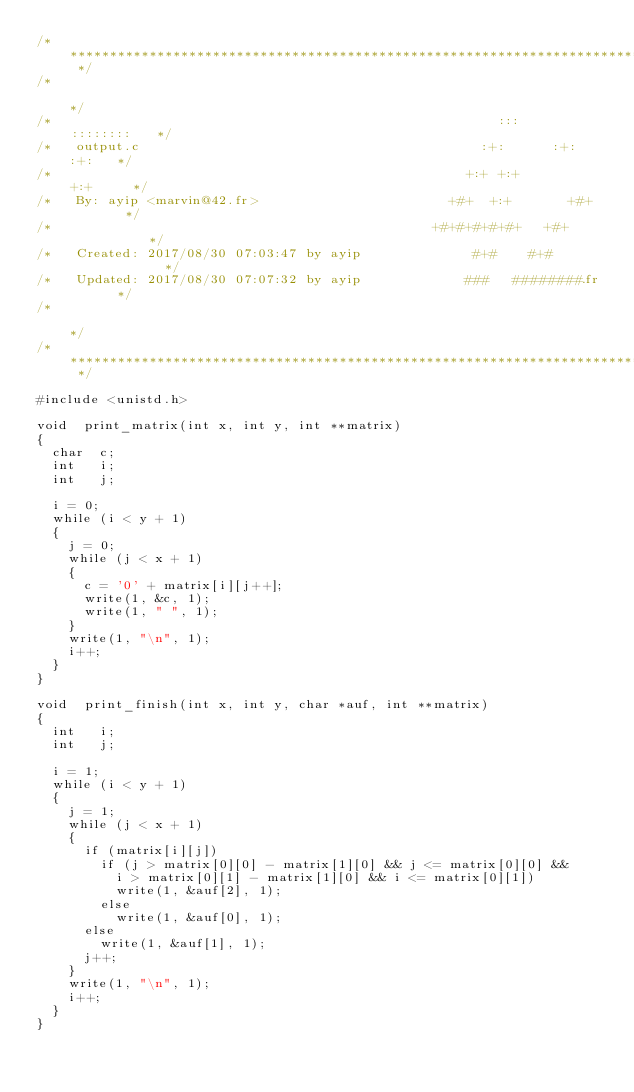<code> <loc_0><loc_0><loc_500><loc_500><_C_>/* ************************************************************************** */
/*                                                                            */
/*                                                        :::      ::::::::   */
/*   output.c                                           :+:      :+:    :+:   */
/*                                                    +:+ +:+         +:+     */
/*   By: ayip <marvin@42.fr>                        +#+  +:+       +#+        */
/*                                                +#+#+#+#+#+   +#+           */
/*   Created: 2017/08/30 07:03:47 by ayip              #+#    #+#             */
/*   Updated: 2017/08/30 07:07:32 by ayip             ###   ########.fr       */
/*                                                                            */
/* ************************************************************************** */

#include <unistd.h>

void	print_matrix(int x, int y, int **matrix)
{
	char	c;
	int		i;
	int		j;

	i = 0;
	while (i < y + 1)
	{
		j = 0;
		while (j < x + 1)
		{
			c = '0' + matrix[i][j++];
			write(1, &c, 1);
			write(1, " ", 1);
		}
		write(1, "\n", 1);
		i++;
	}
}

void	print_finish(int x, int y, char *auf, int **matrix)
{
	int		i;
	int		j;

	i = 1;
	while (i < y + 1)
	{
		j = 1;
		while (j < x + 1)
		{
			if (matrix[i][j])
				if (j > matrix[0][0] - matrix[1][0] && j <= matrix[0][0] &&
					i > matrix[0][1] - matrix[1][0] && i <= matrix[0][1])
					write(1, &auf[2], 1);
				else
					write(1, &auf[0], 1);
			else
				write(1, &auf[1], 1);
			j++;
		}
		write(1, "\n", 1);
		i++;
	}
}
</code> 